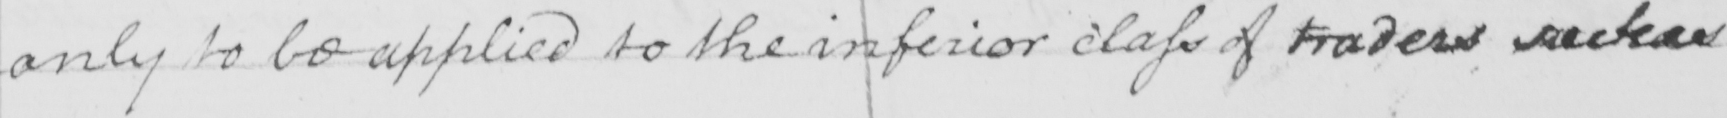What text is written in this handwritten line? only to be applied to the inferior class of traders  <gap/> 